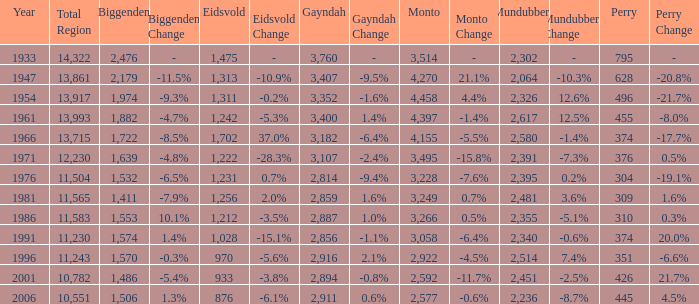What is the Total Region number of hte one that has Eidsvold at 970 and Biggenden larger than 1,570? 0.0. Write the full table. {'header': ['Year', 'Total Region', 'Biggenden', 'Biggenden Change', 'Eidsvold', 'Eidsvold Change', 'Gayndah', 'Gayndah Change', 'Monto', 'Monto Change', 'Mundubbera', 'Mundubbera Change', 'Perry', 'Perry Change'], 'rows': [['1933', '14,322', '2,476', '-', '1,475', '-', '3,760', '-', '3,514', '-', '2,302', '-', '795', '-'], ['1947', '13,861', '2,179', '-11.5%', '1,313', '-10.9%', '3,407', '-9.5%', '4,270', '21.1%', '2,064', '-10.3%', '628', '-20.8%'], ['1954', '13,917', '1,974', '-9.3%', '1,311', '-0.2%', '3,352', '-1.6%', '4,458', '4.4%', '2,326', '12.6%', '496', '-21.7%'], ['1961', '13,993', '1,882', '-4.7%', '1,242', '-5.3%', '3,400', '1.4%', '4,397', '-1.4%', '2,617', '12.5%', '455', '-8.0%'], ['1966', '13,715', '1,722', '-8.5%', '1,702', '37.0%', '3,182', '-6.4%', '4,155', '-5.5%', '2,580', '-1.4%', '374', '-17.7%'], ['1971', '12,230', '1,639', '-4.8%', '1,222', '-28.3%', '3,107', '-2.4%', '3,495', '-15.8%', '2,391', '-7.3%', '376', '0.5%'], ['1976', '11,504', '1,532', '-6.5%', '1,231', '0.7%', '2,814', '-9.4%', '3,228', '-7.6%', '2,395', '0.2%', '304', '-19.1%'], ['1981', '11,565', '1,411', '-7.9%', '1,256', '2.0%', '2,859', '1.6%', '3,249', '0.7%', '2,481', '3.6%', '309', '1.6%'], ['1986', '11,583', '1,553', '10.1%', '1,212', '-3.5%', '2,887', '1.0%', '3,266', '0.5%', '2,355', '-5.1%', '310', '0.3%'], ['1991', '11,230', '1,574', '1.4%', '1,028', '-15.1%', '2,856', '-1.1%', '3,058', '-6.4%', '2,340', '-0.6%', '374', '20.0%'], ['1996', '11,243', '1,570', '-0.3%', '970', '-5.6%', '2,916', '2.1%', '2,922', '-4.5%', '2,514', '7.4%', '351', '-6.6%'], ['2001', '10,782', '1,486', '-5.4%', '933', '-3.8%', '2,894', '-0.8%', '2,592', '-11.7%', '2,451', '-2.5%', '426', '21.7%'], ['2006', '10,551', '1,506', '1.3%', '876', '-6.1%', '2,911', '0.6%', '2,577', '-0.6%', '2,236', '-8.7%', '445', '4.5%']]} 